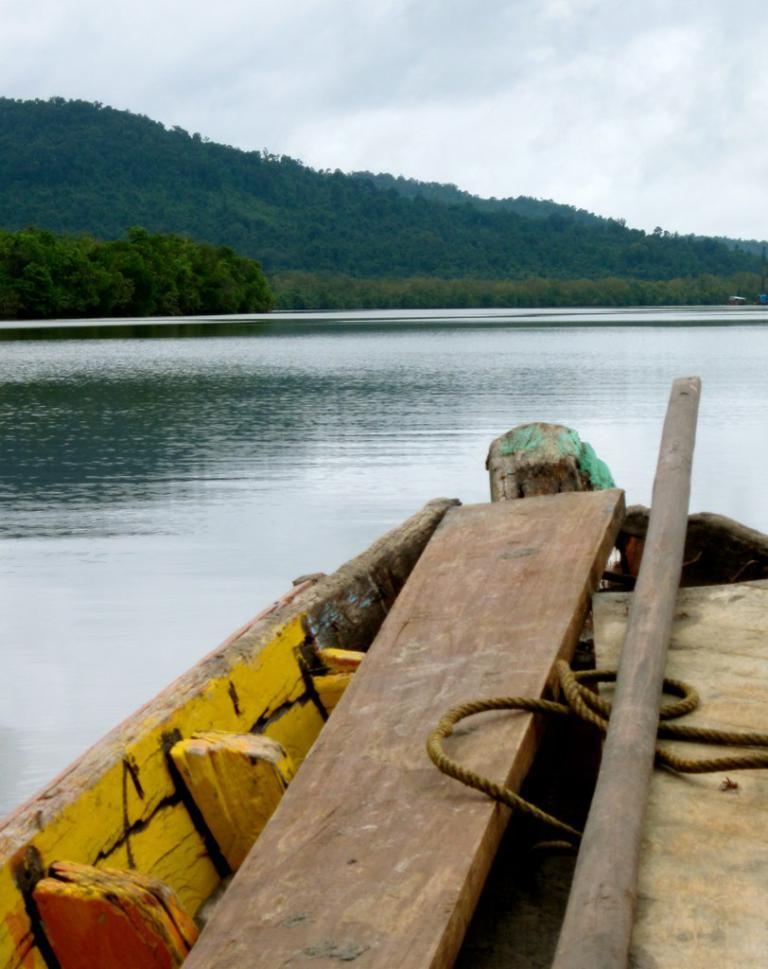What is the main subject of the image? There is a boat in the image. What can be found inside the boat? There are wooden objects and a rope in the boat. What type of vegetation is visible in the image? There are trees visible in the image. What is the primary body of water in the image? There is water visible in the image. What is the color of the sky in the image? The sky is blue and white in color. Where is the school located in the image? There is no school present in the image; it features a boat with wooden objects and a rope. Can you see any hills in the image? There are no hills visible in the image; it primarily features a boat, trees, water, and a blue and white sky. 